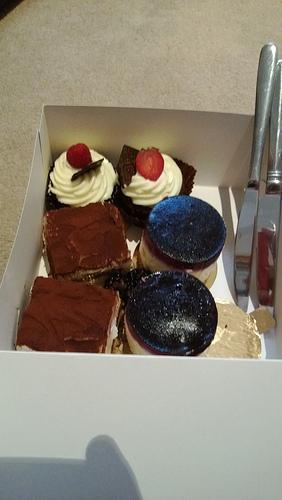How many knives are there?
Give a very brief answer. 2. 